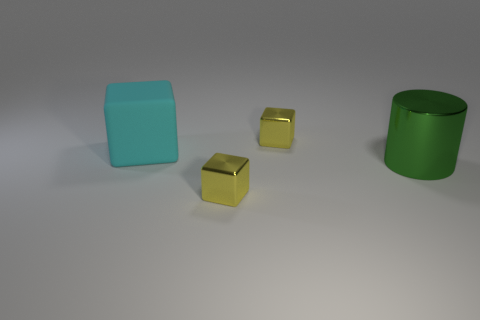Is there anything else that is the same shape as the large green thing?
Offer a terse response. No. There is a big object that is behind the green metal object; what material is it?
Give a very brief answer. Rubber. What material is the cyan block that is the same size as the shiny cylinder?
Provide a short and direct response. Rubber. What is the material of the large object on the left side of the yellow block that is left of the small object that is behind the big cyan cube?
Give a very brief answer. Rubber. Do the cube that is in front of the cyan matte object and the big cylinder have the same size?
Offer a terse response. No. Is the number of big green metal objects greater than the number of small gray matte objects?
Offer a terse response. Yes. How many small things are cyan matte cubes or green cylinders?
Your answer should be very brief. 0. How many other objects are there of the same color as the rubber block?
Give a very brief answer. 0. What number of tiny yellow things have the same material as the big cylinder?
Your answer should be very brief. 2. How many green objects are either small shiny blocks or big metal objects?
Your response must be concise. 1. 